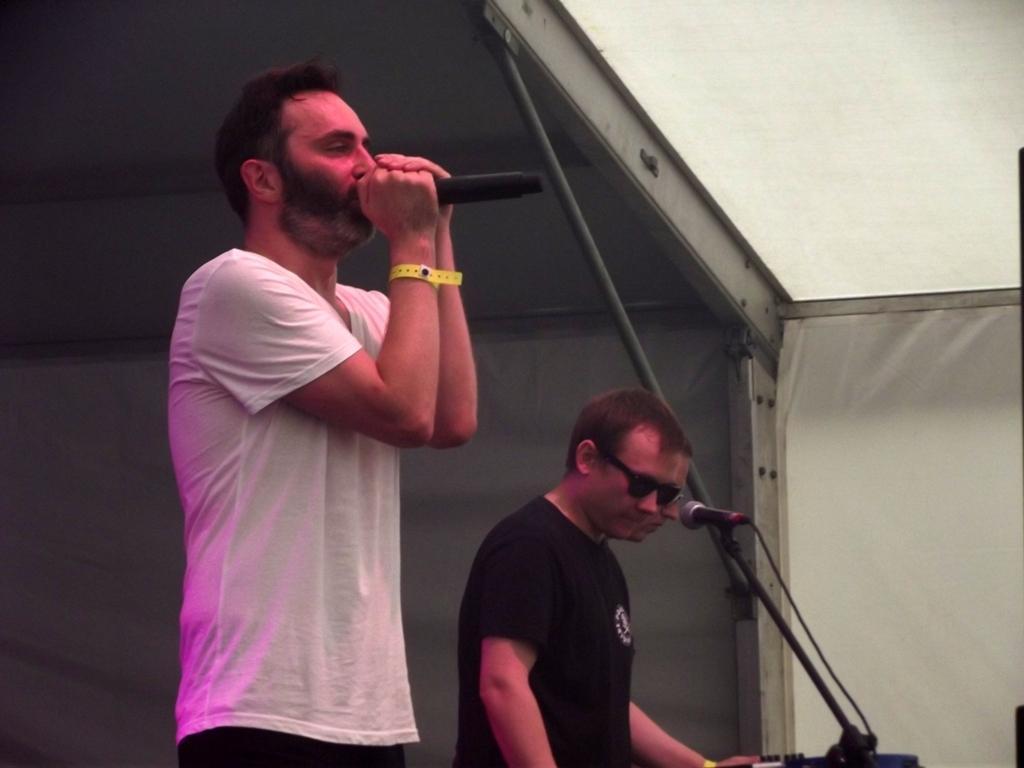How would you summarize this image in a sentence or two? In this image I can see few people standing and one person is holding a mic. I can see stands,white cloth and a shed. 